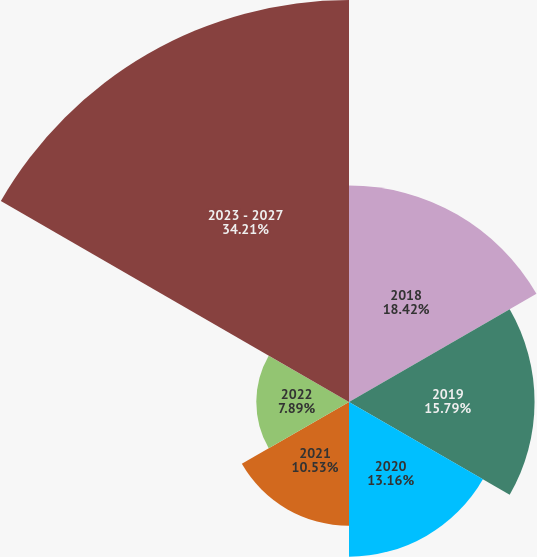Convert chart to OTSL. <chart><loc_0><loc_0><loc_500><loc_500><pie_chart><fcel>2018<fcel>2019<fcel>2020<fcel>2021<fcel>2022<fcel>2023 - 2027<nl><fcel>18.42%<fcel>15.79%<fcel>13.16%<fcel>10.53%<fcel>7.89%<fcel>34.21%<nl></chart> 